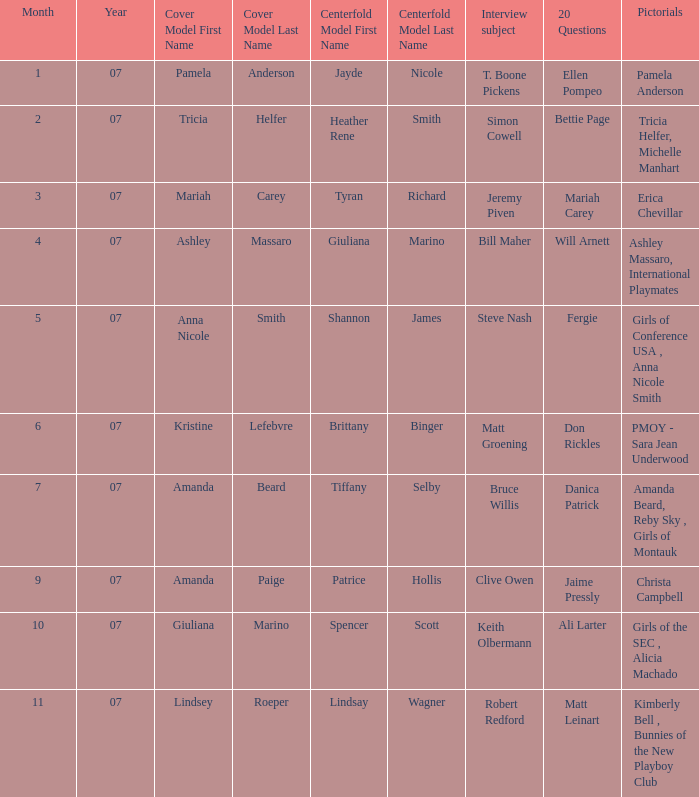Who answered the 20 questions on 10-07? Ali Larter. 